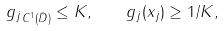<formula> <loc_0><loc_0><loc_500><loc_500>\| g _ { j } \| _ { C ^ { 1 } ( { \bar { D } } ) } \leq K , \quad g _ { j } ( x _ { j } ) \geq 1 / K ,</formula> 